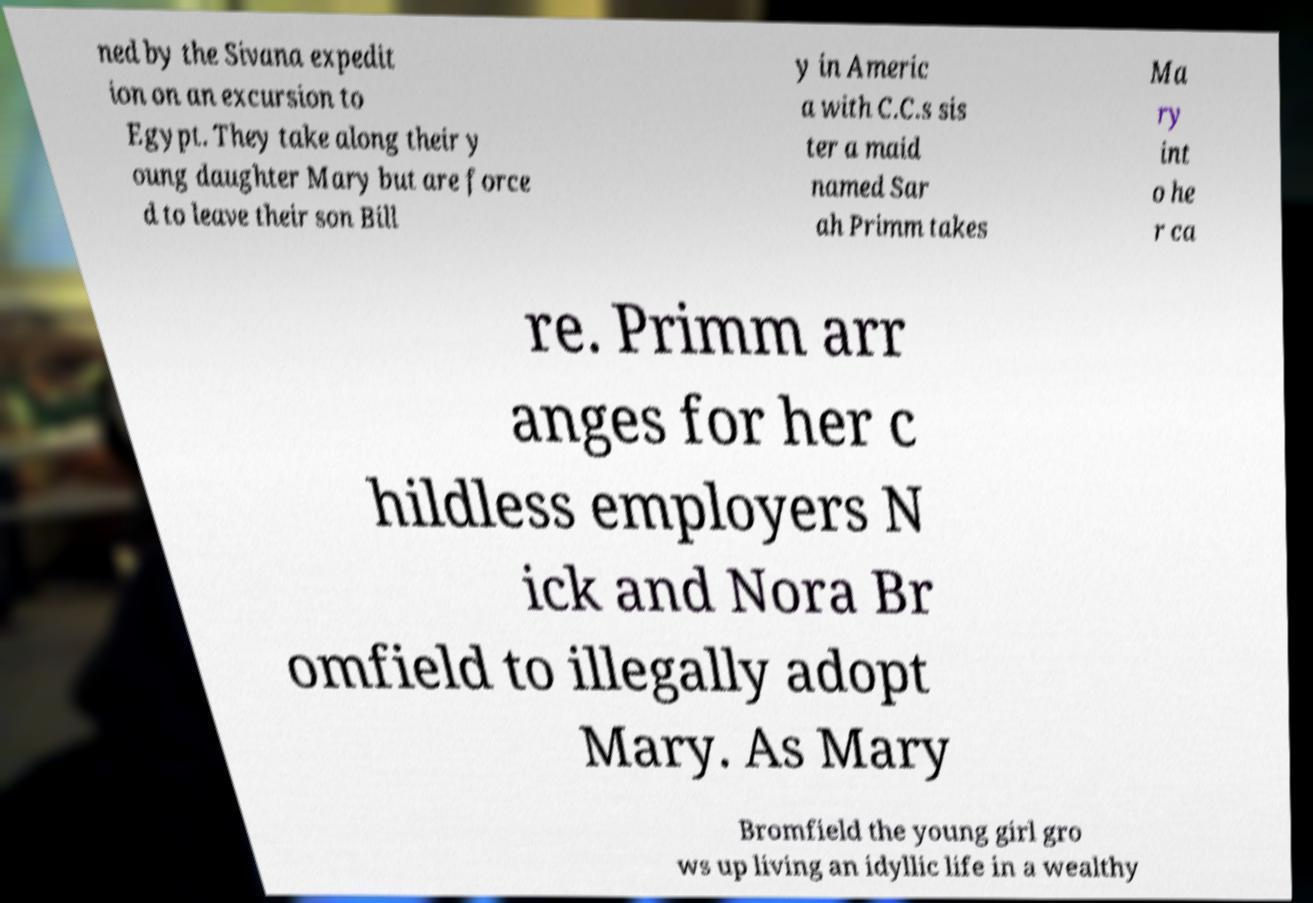For documentation purposes, I need the text within this image transcribed. Could you provide that? ned by the Sivana expedit ion on an excursion to Egypt. They take along their y oung daughter Mary but are force d to leave their son Bill y in Americ a with C.C.s sis ter a maid named Sar ah Primm takes Ma ry int o he r ca re. Primm arr anges for her c hildless employers N ick and Nora Br omfield to illegally adopt Mary. As Mary Bromfield the young girl gro ws up living an idyllic life in a wealthy 